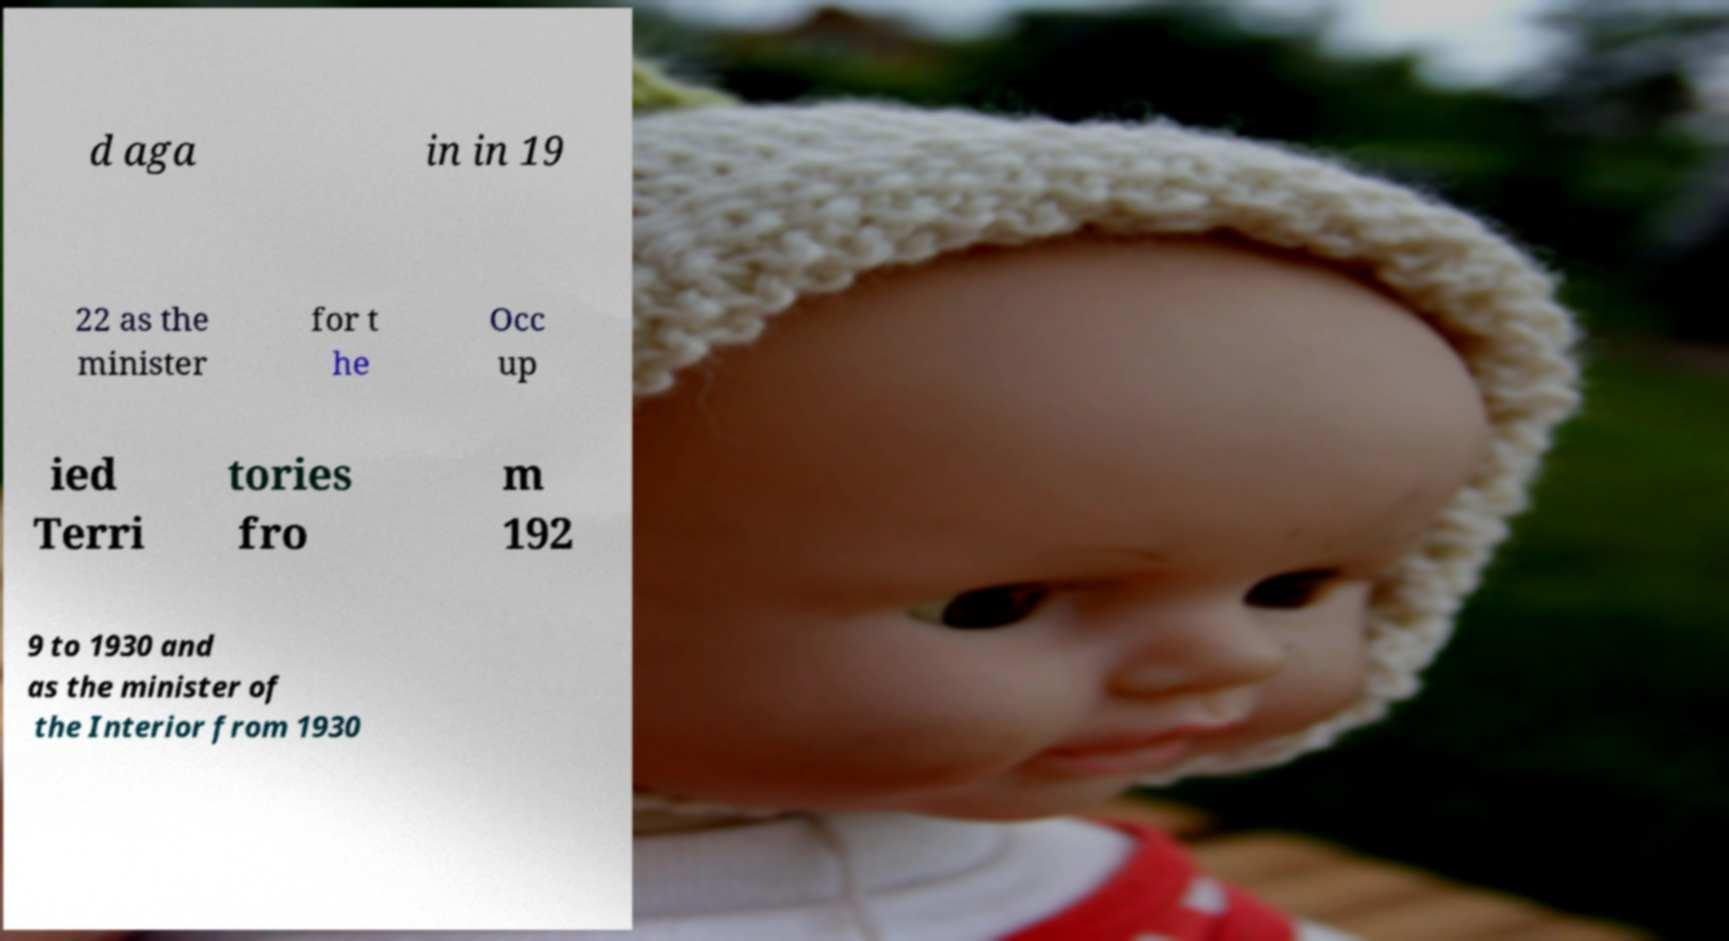There's text embedded in this image that I need extracted. Can you transcribe it verbatim? d aga in in 19 22 as the minister for t he Occ up ied Terri tories fro m 192 9 to 1930 and as the minister of the Interior from 1930 